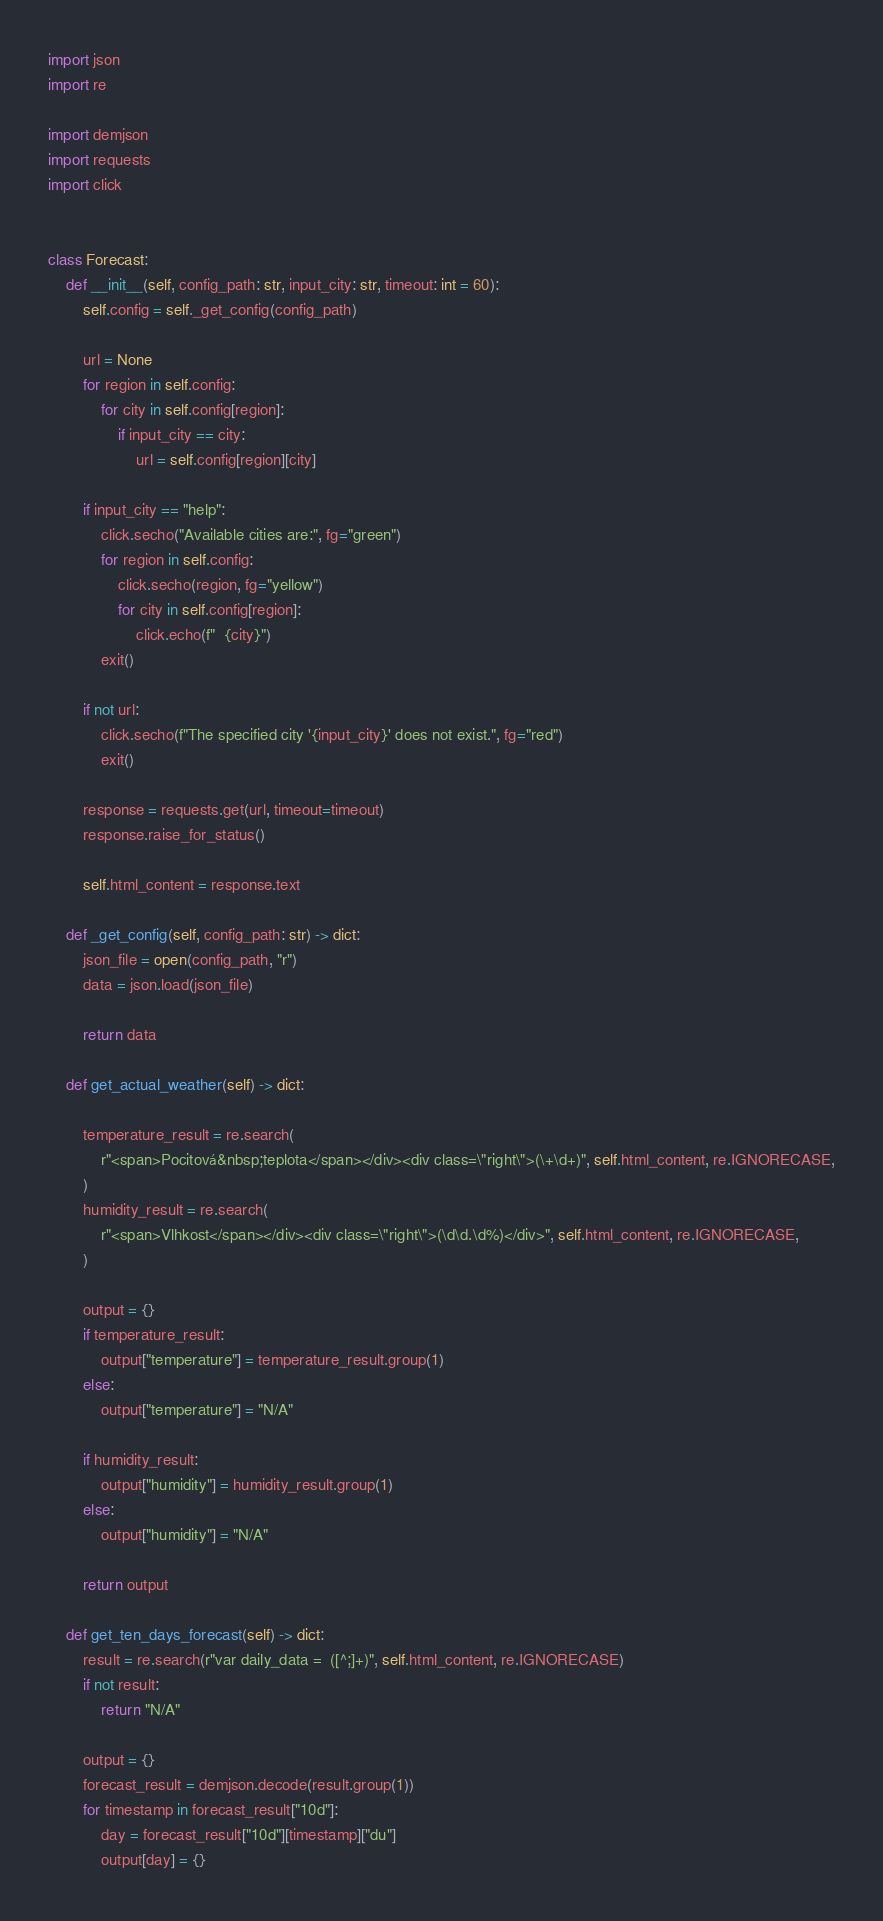Convert code to text. <code><loc_0><loc_0><loc_500><loc_500><_Python_>import json
import re

import demjson
import requests
import click


class Forecast:
    def __init__(self, config_path: str, input_city: str, timeout: int = 60):
        self.config = self._get_config(config_path)

        url = None
        for region in self.config:
            for city in self.config[region]:
                if input_city == city:
                    url = self.config[region][city]

        if input_city == "help":
            click.secho("Available cities are:", fg="green")
            for region in self.config:
                click.secho(region, fg="yellow")
                for city in self.config[region]:
                    click.echo(f"  {city}")
            exit()

        if not url:
            click.secho(f"The specified city '{input_city}' does not exist.", fg="red")
            exit()

        response = requests.get(url, timeout=timeout)
        response.raise_for_status()

        self.html_content = response.text

    def _get_config(self, config_path: str) -> dict:
        json_file = open(config_path, "r")
        data = json.load(json_file)

        return data

    def get_actual_weather(self) -> dict:

        temperature_result = re.search(
            r"<span>Pocitová&nbsp;teplota</span></div><div class=\"right\">(\+\d+)", self.html_content, re.IGNORECASE,
        )
        humidity_result = re.search(
            r"<span>Vlhkost</span></div><div class=\"right\">(\d\d.\d%)</div>", self.html_content, re.IGNORECASE,
        )

        output = {}
        if temperature_result:
            output["temperature"] = temperature_result.group(1)
        else:
            output["temperature"] = "N/A"

        if humidity_result:
            output["humidity"] = humidity_result.group(1)
        else:
            output["humidity"] = "N/A"

        return output

    def get_ten_days_forecast(self) -> dict:
        result = re.search(r"var daily_data =  ([^;]+)", self.html_content, re.IGNORECASE)
        if not result:
            return "N/A"

        output = {}
        forecast_result = demjson.decode(result.group(1))
        for timestamp in forecast_result["10d"]:
            day = forecast_result["10d"][timestamp]["du"]
            output[day] = {}
</code> 